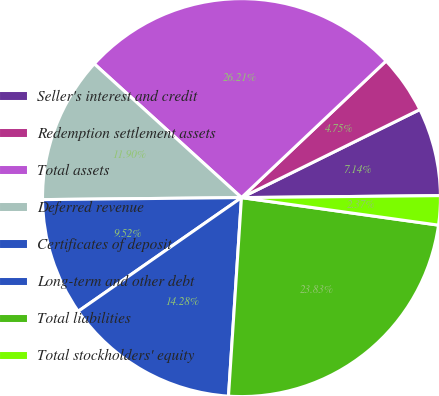Convert chart to OTSL. <chart><loc_0><loc_0><loc_500><loc_500><pie_chart><fcel>Seller's interest and credit<fcel>Redemption settlement assets<fcel>Total assets<fcel>Deferred revenue<fcel>Certificates of deposit<fcel>Long-term and other debt<fcel>Total liabilities<fcel>Total stockholders' equity<nl><fcel>7.14%<fcel>4.75%<fcel>26.21%<fcel>11.9%<fcel>9.52%<fcel>14.28%<fcel>23.83%<fcel>2.37%<nl></chart> 